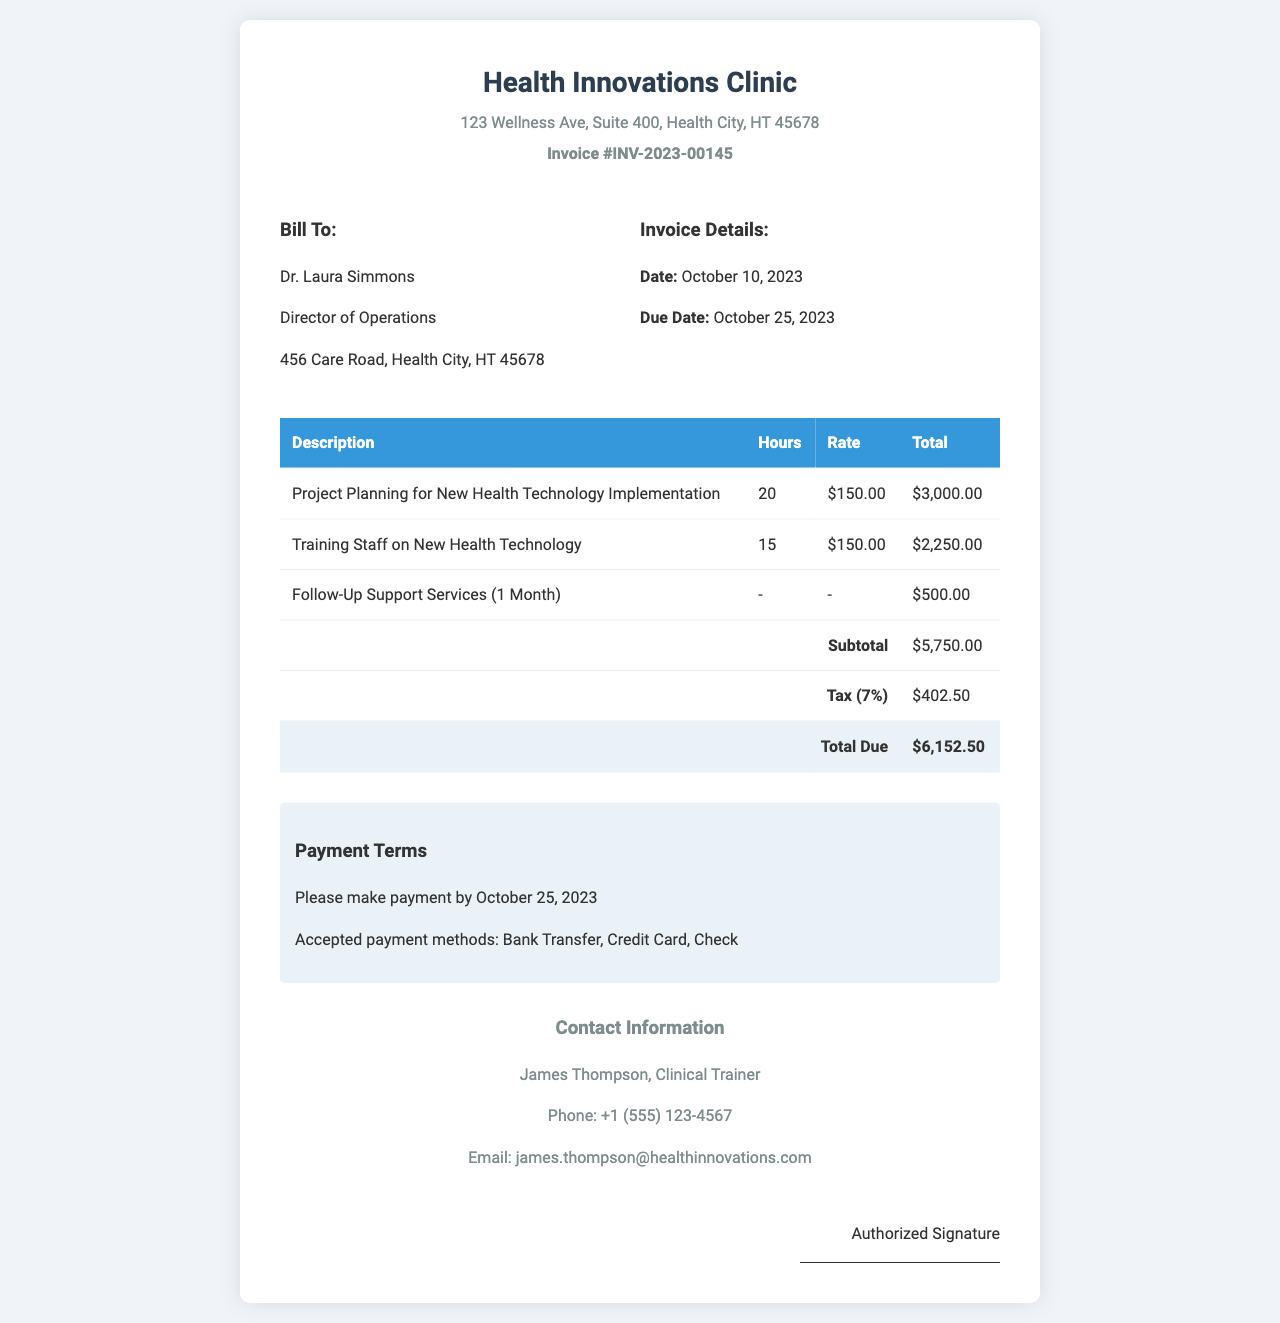What is the invoice number? The invoice number is listed in the document and identifies the invoice uniquely.
Answer: INV-2023-00145 Who is the bill to? The bill to section contains the name and position of the person being billed.
Answer: Dr. Laura Simmons What is the due date of the invoice? The due date is specified in the invoice details section.
Answer: October 25, 2023 How much is charged for Follow-Up Support Services? The total amount for Follow-Up Support Services is recorded in the total line for that service.
Answer: $500.00 What is the subtotal amount before tax? The subtotal is the sum of all services before tax is applied, noted in the invoice table.
Answer: $5,750.00 How many hours were billed for training staff? The number of hours billed for training staff is documented in the invoice.
Answer: 15 What is the percentage of tax applied? The document specifies the tax rate used to calculate the tax amount.
Answer: 7% What is the total amount due? The total amount due is calculated including the subtotal and tax, clearly displayed at the bottom of the invoice.
Answer: $6,152.50 What are the accepted payment methods? The payment terms section lists the accepted methods for payment.
Answer: Bank Transfer, Credit Card, Check 